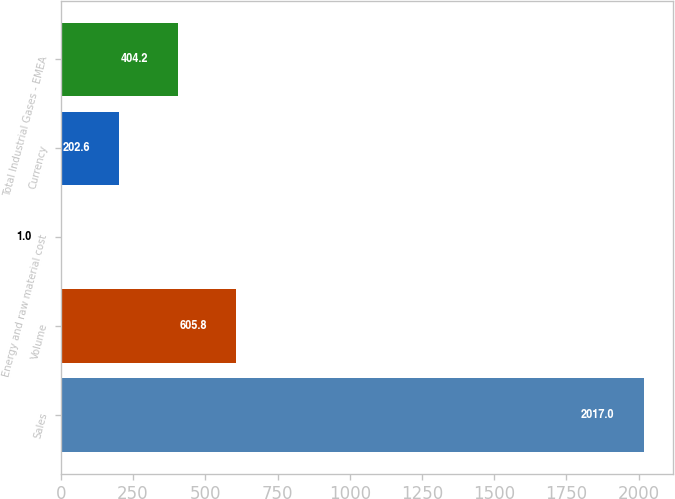Convert chart. <chart><loc_0><loc_0><loc_500><loc_500><bar_chart><fcel>Sales<fcel>Volume<fcel>Energy and raw material cost<fcel>Currency<fcel>Total Industrial Gases - EMEA<nl><fcel>2017<fcel>605.8<fcel>1<fcel>202.6<fcel>404.2<nl></chart> 